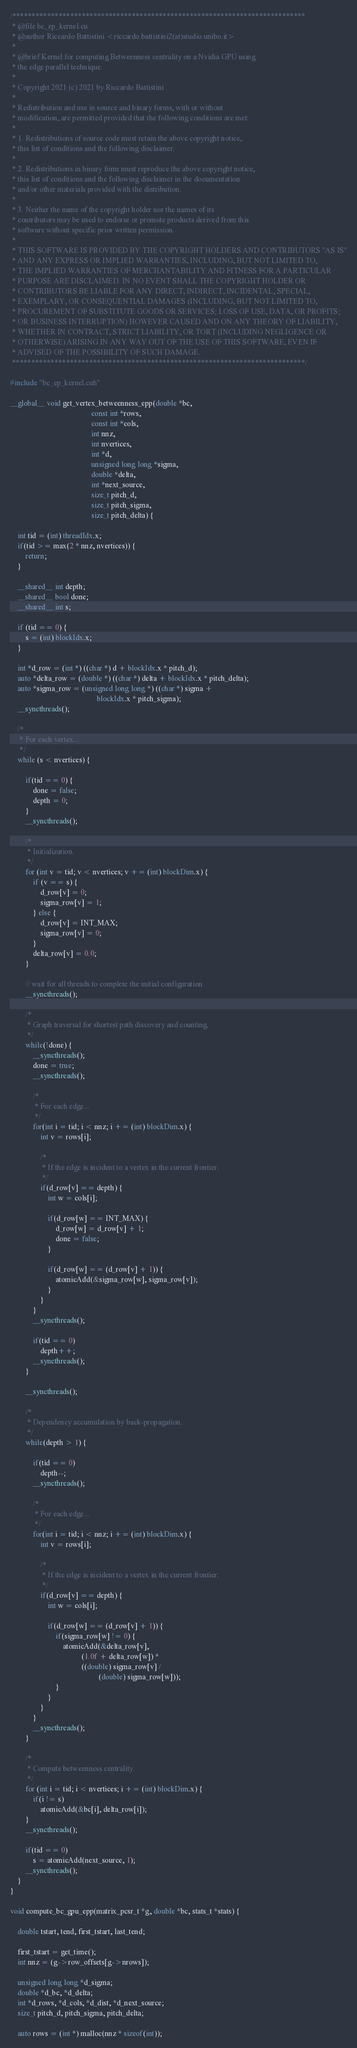Convert code to text. <code><loc_0><loc_0><loc_500><loc_500><_Cuda_>/****************************************************************************
 * @file bc_ep_kernel.cu
 * @author Riccardo Battistini <riccardo.battistini2(at)studio.unibo.it>
 *
 * @brief Kernel for computing Betweenness centrality on a Nvidia GPU using
 * the edge parallel technique.
 *
 * Copyright 2021 (c) 2021 by Riccardo Battistini
 *
 * Redistribution and use in source and binary forms, with or without
 * modification, are permitted provided that the following conditions are met:
 *
 * 1. Redistributions of source code must retain the above copyright notice,
 * this list of conditions and the following disclaimer.
 *
 * 2. Redistributions in binary form must reproduce the above copyright notice,
 * this list of conditions and the following disclaimer in the documentation
 * and/or other materials provided with the distribution.
 *
 * 3. Neither the name of the copyright holder nor the names of its
 * contributors may be used to endorse or promote products derived from this
 * software without specific prior written permission.
 *
 * THIS SOFTWARE IS PROVIDED BY THE COPYRIGHT HOLDERS AND CONTRIBUTORS "AS IS"
 * AND ANY EXPRESS OR IMPLIED WARRANTIES, INCLUDING, BUT NOT LIMITED TO,
 * THE IMPLIED WARRANTIES OF MERCHANTABILITY AND FITNESS FOR A PARTICULAR
 * PURPOSE ARE DISCLAIMED. IN NO EVENT SHALL THE COPYRIGHT HOLDER OR
 * CONTRIBUTORS BE LIABLE FOR ANY DIRECT, INDIRECT, INCIDENTAL, SPECIAL,
 * EXEMPLARY, OR CONSEQUENTIAL DAMAGES (INCLUDING, BUT NOT LIMITED TO,
 * PROCUREMENT OF SUBSTITUTE GOODS OR SERVICES; LOSS OF USE, DATA, OR PROFITS;
 * OR BUSINESS INTERRUPTION) HOWEVER CAUSED AND ON ANY THEORY OF LIABILITY,
 * WHETHER IN CONTRACT, STRICT LIABILITY, OR TORT (INCLUDING NEGLIGENCE OR
 * OTHERWISE) ARISING IN ANY WAY OUT OF THE USE OF THIS SOFTWARE, EVEN IF
 * ADVISED OF THE POSSIBILITY OF SUCH DAMAGE.
 ****************************************************************************/

#include "bc_ep_kernel.cuh"

__global__ void get_vertex_betweenness_epp(double *bc,
                                           const int *rows,
                                           const int *cols,
                                           int nnz,
                                           int nvertices,
                                           int *d,
                                           unsigned long long *sigma,
                                           double *delta,
                                           int *next_source,
                                           size_t pitch_d,
                                           size_t pitch_sigma,
                                           size_t pitch_delta) {

    int tid = (int) threadIdx.x;
    if(tid >= max(2 * nnz, nvertices)) {
        return;
    }

    __shared__ int depth;
    __shared__ bool done;
    __shared__ int s;

    if (tid == 0) {
        s = (int) blockIdx.x;
    }

    int *d_row = (int *) ((char *) d + blockIdx.x * pitch_d);
    auto *delta_row = (double *) ((char *) delta + blockIdx.x * pitch_delta);
    auto *sigma_row = (unsigned long long *) ((char *) sigma +
                                              blockIdx.x * pitch_sigma);
    __syncthreads();

    /*
     * For each vertex...
     */
    while (s < nvertices) {

        if(tid == 0) {
            done = false;
            depth = 0;
        }
        __syncthreads();

        /*
         * Initialization.
         */
        for (int v = tid; v < nvertices; v += (int) blockDim.x) {
            if (v == s) {
                d_row[v] = 0;
                sigma_row[v] = 1;
            } else {
                d_row[v] = INT_MAX;
                sigma_row[v] = 0;
            }
            delta_row[v] = 0.0;
        }

        // wait for all threads to complete the initial configuration
        __syncthreads();

        /*
         * Graph traversal for shortest path discovery and counting.
         */
        while(!done) {
            __syncthreads();
            done = true;
            __syncthreads();

            /*
             * For each edge...
             */
            for(int i = tid; i < nnz; i += (int) blockDim.x) {
                int v = rows[i];

                /*
                 * If the edge is incident to a vertex in the current frontier.
                 */
                if(d_row[v] == depth) {
                    int w = cols[i];

                    if(d_row[w] == INT_MAX) {
                        d_row[w] = d_row[v] + 1;
                        done = false;
                    }

                    if(d_row[w] == (d_row[v] + 1)) {
                        atomicAdd(&sigma_row[w], sigma_row[v]);
                    }
                }
            }
            __syncthreads();

            if(tid == 0)
                depth++;
            __syncthreads();
        }

        __syncthreads();

        /*
         * Dependency accumulation by back-propagation.
         */
        while(depth > 1) {

            if(tid == 0)
                depth--;
            __syncthreads();

            /*
             * For each edge...
             */
            for(int i = tid; i < nnz; i += (int) blockDim.x) {
                int v = rows[i];

                /*
                 * If the edge is incident to a vertex in the current frontier.
                 */
                if(d_row[v] == depth) {
                    int w = cols[i];

                    if(d_row[w] == (d_row[v] + 1)) {
                        if(sigma_row[w] != 0) {
                            atomicAdd(&delta_row[v],
                                      (1.0f + delta_row[w]) *
                                      ((double) sigma_row[v] /
                                               (double) sigma_row[w]));
                        }
                    }
                }
            }
            __syncthreads();
        }

        /*
         * Compute betweenness centrality.
         */
        for (int i = tid; i < nvertices; i += (int) blockDim.x) {
            if(i != s)
                atomicAdd(&bc[i], delta_row[i]);
        }
        __syncthreads();

        if(tid == 0)
            s = atomicAdd(next_source, 1);
        __syncthreads();
    }
}

void compute_bc_gpu_epp(matrix_pcsr_t *g, double *bc, stats_t *stats) {

    double tstart, tend, first_tstart, last_tend;

    first_tstart = get_time();
    int nnz = (g->row_offsets[g->nrows]);

    unsigned long long *d_sigma;
    double *d_bc, *d_delta;
    int *d_rows, *d_cols, *d_dist, *d_next_source;
    size_t pitch_d, pitch_sigma, pitch_delta;

    auto rows = (int *) malloc(nnz * sizeof(int));</code> 